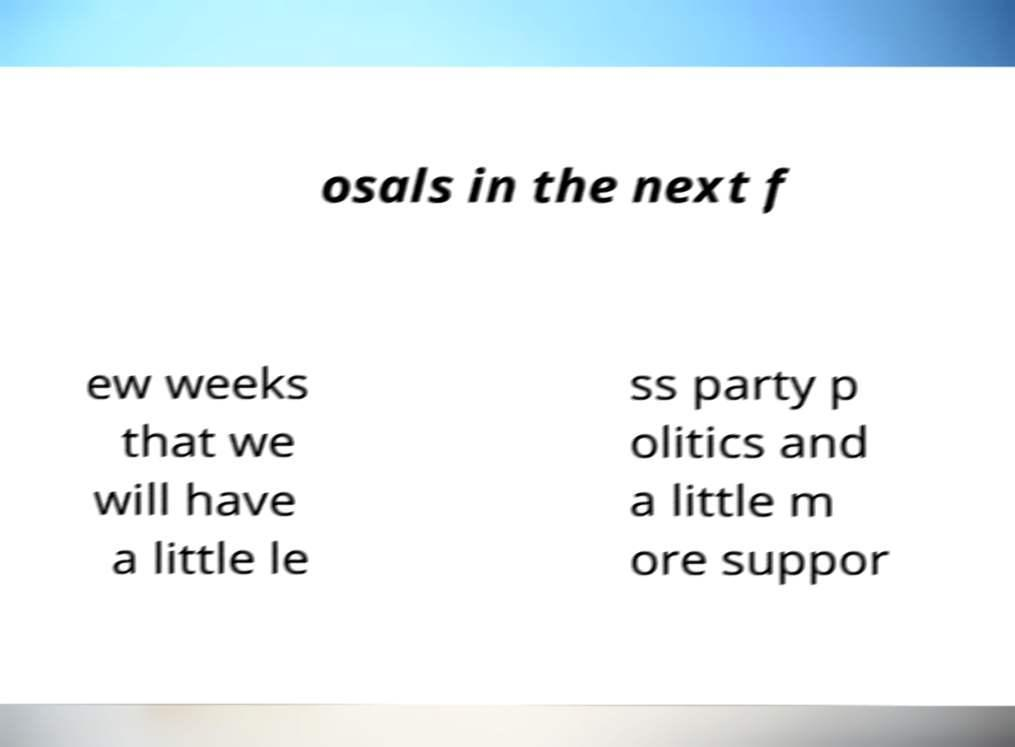Can you accurately transcribe the text from the provided image for me? osals in the next f ew weeks that we will have a little le ss party p olitics and a little m ore suppor 